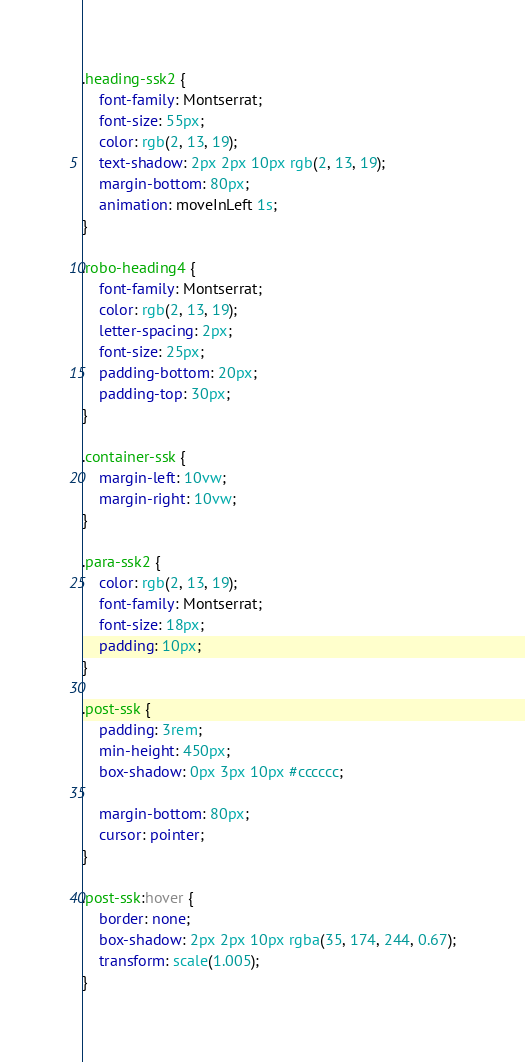<code> <loc_0><loc_0><loc_500><loc_500><_CSS_>.heading-ssk2 {
    font-family: Montserrat;
    font-size: 55px;
    color: rgb(2, 13, 19);
    text-shadow: 2px 2px 10px rgb(2, 13, 19);
    margin-bottom: 80px;
    animation: moveInLeft 1s;
}

.robo-heading4 {
    font-family: Montserrat;
    color: rgb(2, 13, 19);
    letter-spacing: 2px;
    font-size: 25px;
    padding-bottom: 20px;
    padding-top: 30px;
}

.container-ssk {
    margin-left: 10vw;
    margin-right: 10vw;
}

.para-ssk2 {
    color: rgb(2, 13, 19);
    font-family: Montserrat;
    font-size: 18px;
    padding: 10px;
}

.post-ssk {
    padding: 3rem;
    min-height: 450px;
    box-shadow: 0px 3px 10px #cccccc;

    margin-bottom: 80px;
    cursor: pointer;
}

.post-ssk:hover {
    border: none;
    box-shadow: 2px 2px 10px rgba(35, 174, 244, 0.67);
    transform: scale(1.005);
}
</code> 